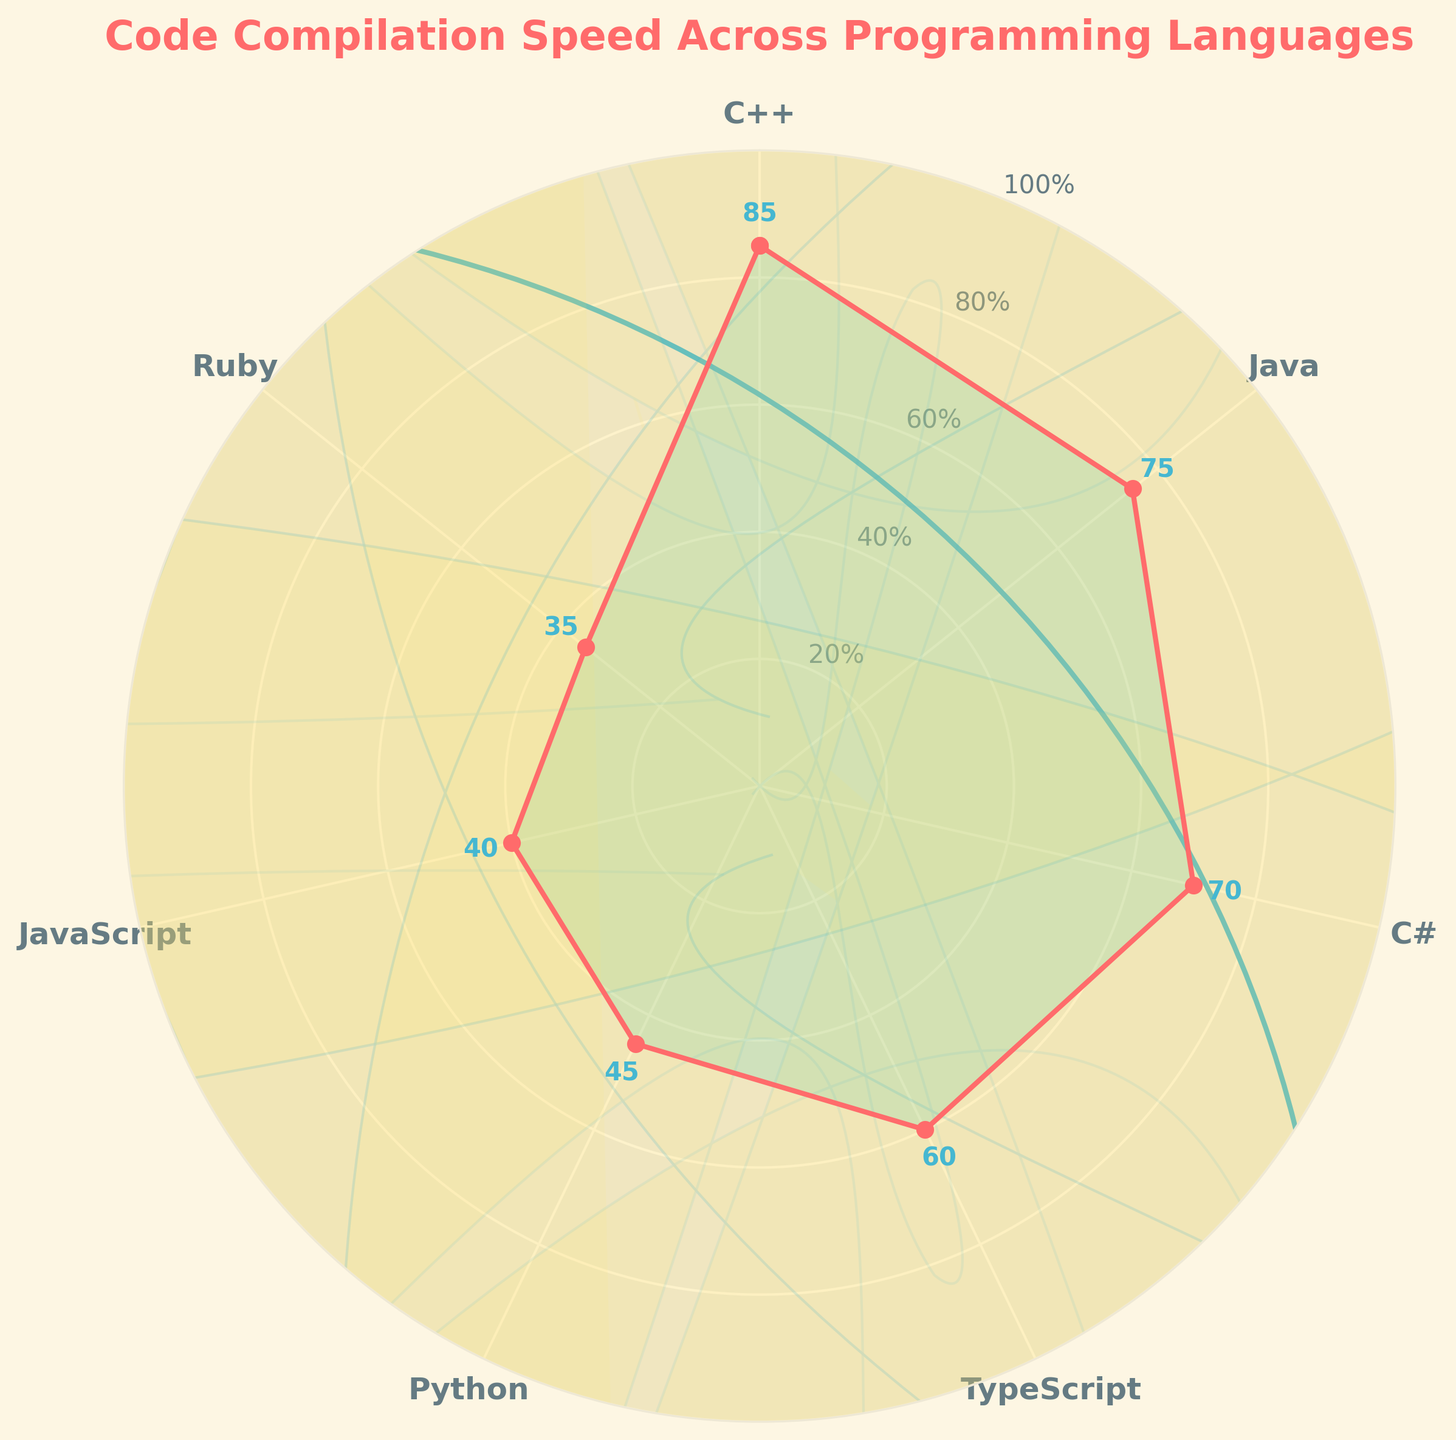What's the title of the plot? The title is located at the top of the figure and is clearly labeled.
Answer: Code Compilation Speed Across Programming Languages Which programming language has the highest compilation speed? Look for the data point at the highest vertical position on the plot.
Answer: C++ What are the speeds for Python and JavaScript? Identify the data points corresponding to Python and JavaScript and read their values. Python is 45 and JavaScript is 40.
Answer: Python: 45, JavaScript: 40 How many programming languages are displayed? Count the number of distinct labels around the circumference of the chart.
Answer: 7 What is the average compilation speed of all the programming languages? Add each speed value together and divide by the number of languages: (85 + 75 + 70 + 60 + 45 + 40 + 35)/7 ≈ 58.57
Answer: 58.57 Which language has the lowest compilation speed, and what is it? Identify the lowest point on the plot and note its value.
Answer: Ruby, 35 Compare the compilation speeds of C# and TypeScript. Which is faster? Locate the data points for C# and TypeScript, then compare their values.
Answer: C# is faster than TypeScript What is the range of the compilation speeds? Subtract the minimum speed value from the maximum speed value: 85 - 35 = 50
Answer: 50 What are the intervals of the radial grid lines in the gauge chart? Identify the values marked at the radial grid lines around the chart.
Answer: 20% intervals 